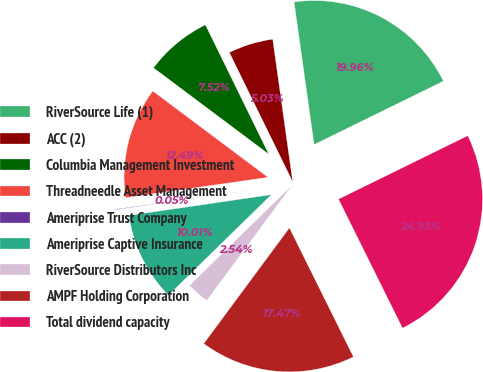<chart> <loc_0><loc_0><loc_500><loc_500><pie_chart><fcel>RiverSource Life (1)<fcel>ACC (2)<fcel>Columbia Management Investment<fcel>Threadneedle Asset Management<fcel>Ameriprise Trust Company<fcel>Ameriprise Captive Insurance<fcel>RiverSource Distributors Inc<fcel>AMPF Holding Corporation<fcel>Total dividend capacity<nl><fcel>19.96%<fcel>5.03%<fcel>7.52%<fcel>12.49%<fcel>0.05%<fcel>10.01%<fcel>2.54%<fcel>17.47%<fcel>24.93%<nl></chart> 